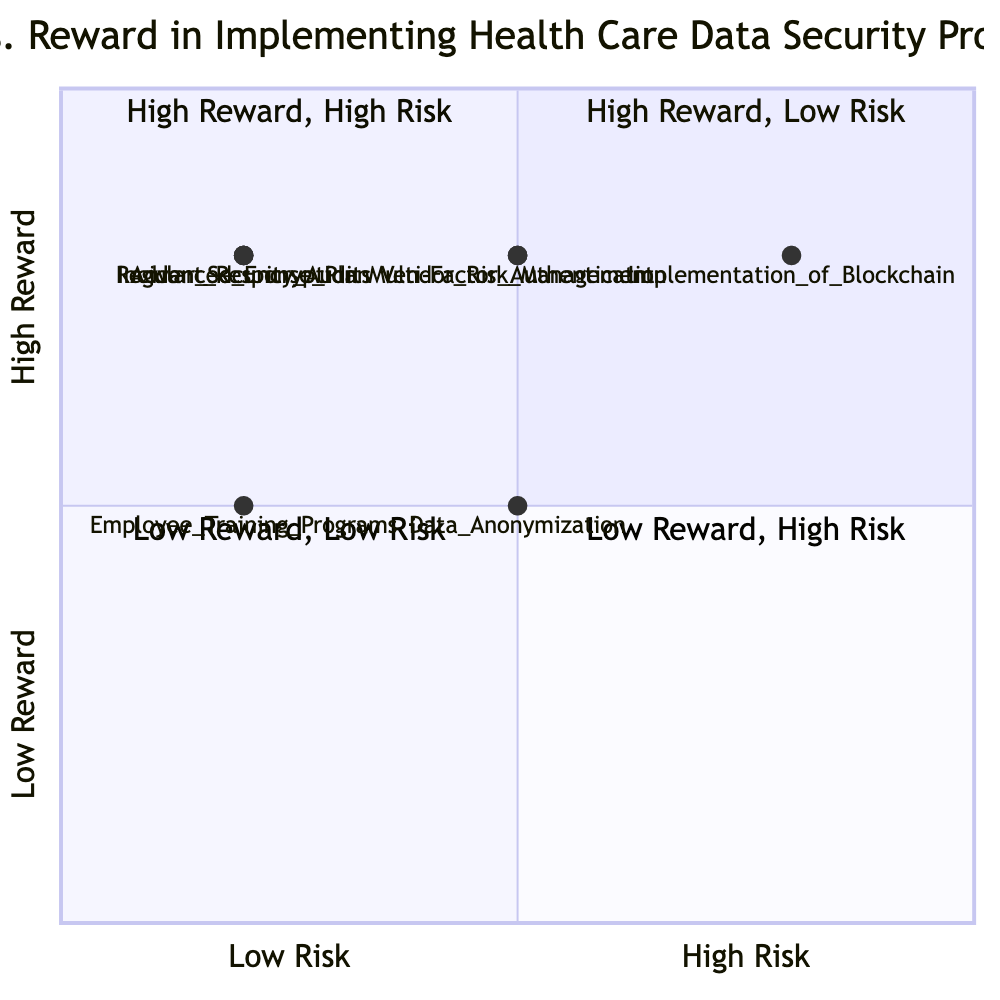What are the two techniques in the High Reward, Low Risk quadrant? The High Reward, Low Risk quadrant has three elements: Advanced Encryption, Regular Security Audits, and Incident Response Plan. The two techniques among these are Advanced Encryption and Regular Security Audits.
Answer: Advanced Encryption, Regular Security Audits How many techniques are in the Low Reward, High Risk quadrant? There is only one technique in this quadrant, which is Implementation of Blockchain.
Answer: 1 What is the reward level of Data Anonymization? The reward level for Data Anonymization is Medium, as indicated by its position in the quadrant chart.
Answer: Medium Which technique has the highest risk? The technique with the highest risk is Implementation of Blockchain, situated in the High Reward, High Risk quadrant.
Answer: Implementation of Blockchain Do any procedures fall into the Low Reward, Low Risk quadrant? There are no procedures listed in the Low Reward, Low Risk quadrant, as all of them have either medium rewards or are in a different quadrant.
Answer: No Which element is associated with Multi-Factor Authentication? Multi-Factor Authentication is associated with a risk level of Medium and a reward level of High, making it one of the prominent techniques in data security.
Answer: Medium Risk, High Reward What is the description of the Incident Response Plan? The description for the Incident Response Plan states that it is about establishing a comprehensive plan for responding to data breaches quickly and efficiently to mitigate damage.
Answer: Establishing a comprehensive plan for responding to data breaches quickly and efficiently to mitigate damage How many total techniques are in the High Reward quadrant? In the High Reward quadrants, there are five techniques, which include Advanced Encryption, Multi-Factor Authentication, Regular Security Audits, Implementation of Blockchain, and Vendor Risk Management.
Answer: 5 What quadrant does Employee Training Programs fall in? Employee Training Programs fall into the High Reward, Medium Risk quadrant due to its risk and reward metrics.
Answer: High Reward, Medium Risk 